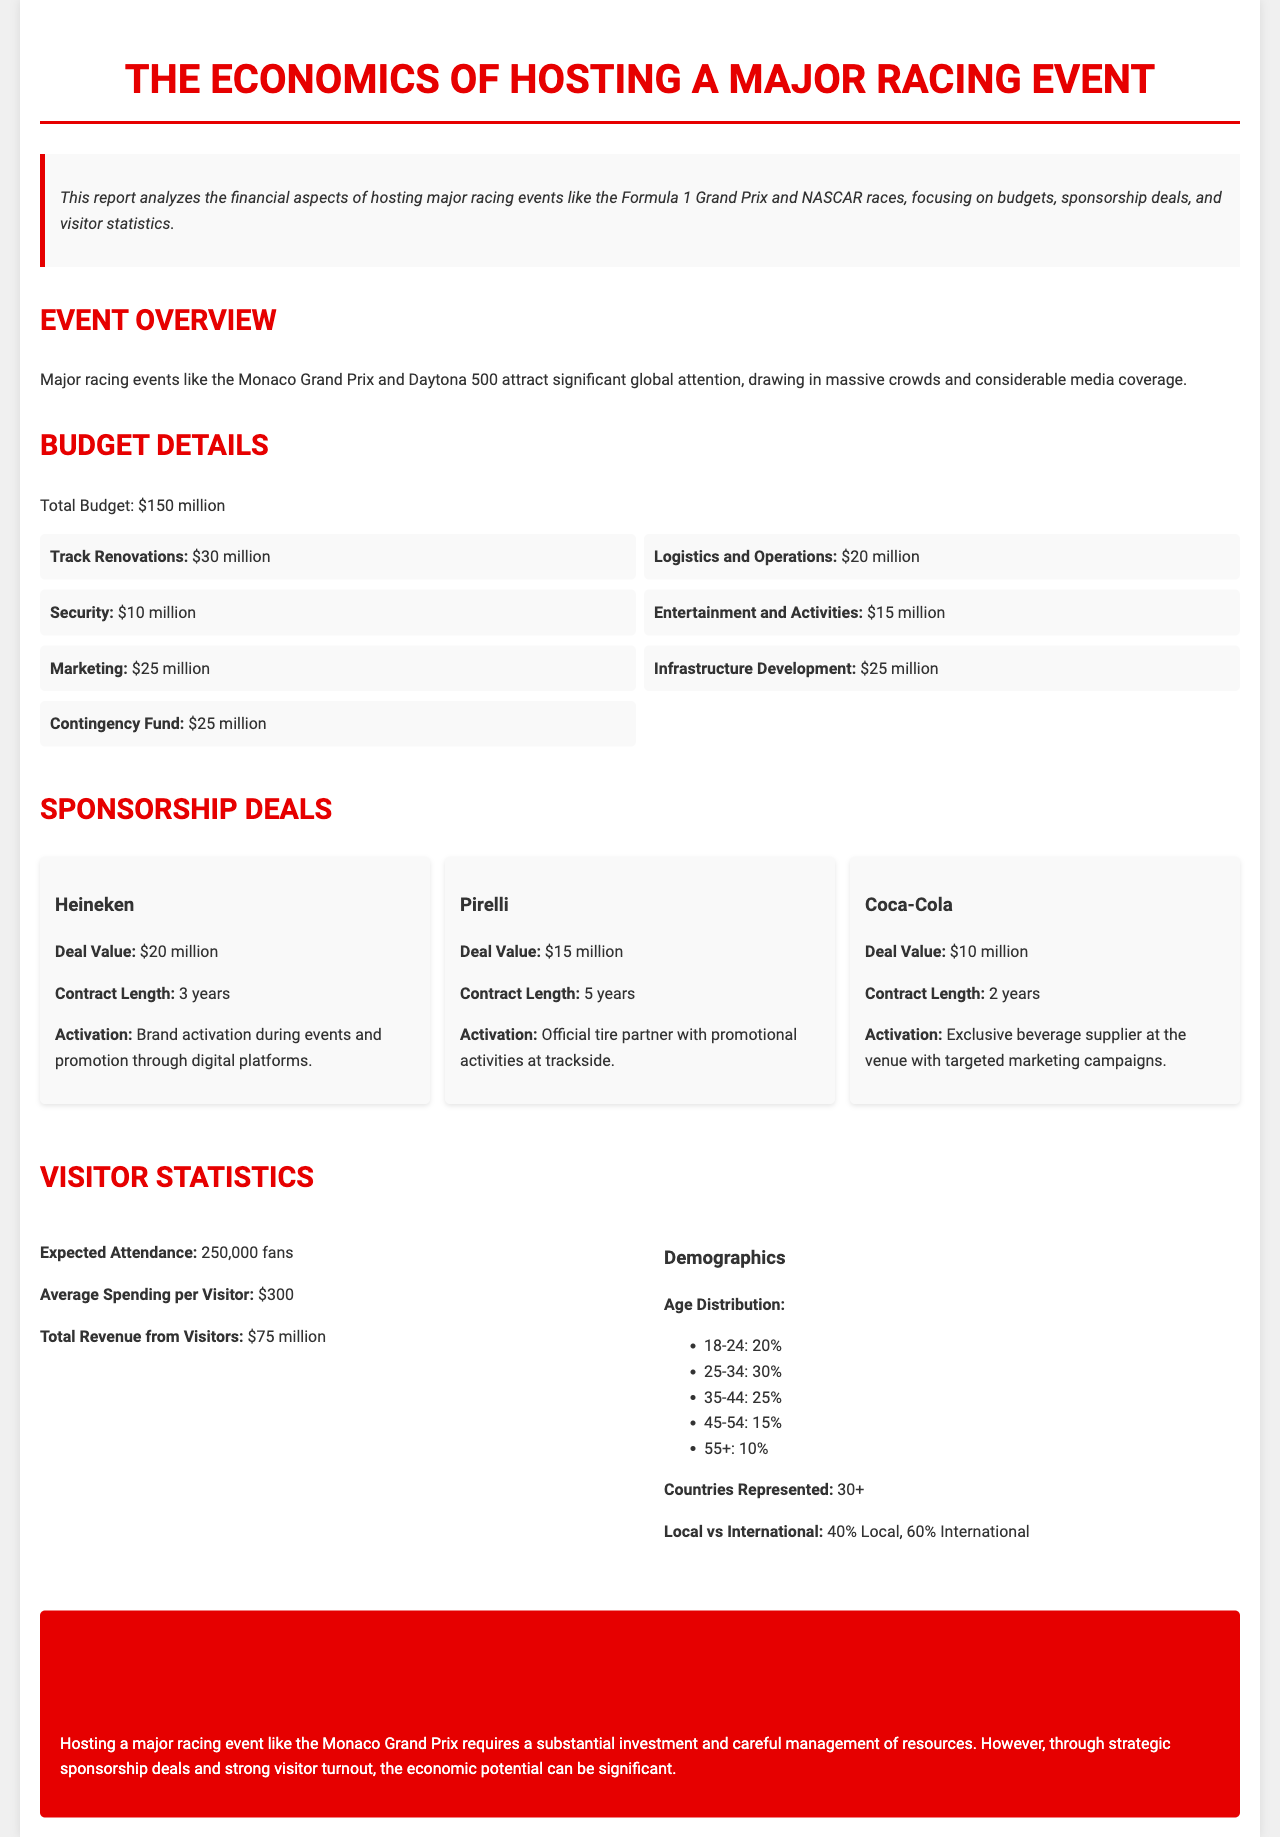What is the total budget for hosting the event? The total budget for the event is explicitly stated in the document.
Answer: $150 million What are the total expected attendance figures? The document specifies the expected attendance for the event, providing a clear number.
Answer: 250,000 fans Which company has a sponsorship deal valued at $20 million? The document lists sponsorship deals and their respective values, including the name of the company with the highest value.
Answer: Heineken What is the average spending per visitor? The average spending per visitor is mentioned in the visitor statistics section of the document.
Answer: $300 What percentage of attendees are 25-34 years old? The age distribution of attendees is presented in percentage form, allowing for a straightforward extraction of information.
Answer: 30% What is the contract length for the Pirelli sponsorship deal? The document details the contract lengths for sponsorships, specifically noting Pirelli's duration.
Answer: 5 years What is the total revenue generated from visitors? Revenue figures generated from visitor spending are outlined in the visitor statistics section.
Answer: $75 million Which category has the highest budget allocation? The budget breakdown section reveals the amounts allocated to different categories, leading to the identification of the highest one.
Answer: Track Renovations What is the local versus international attendance percentage? The demographics section of the visitor statistics highlights the distribution of local versus international attendees.
Answer: 40% Local, 60% International 